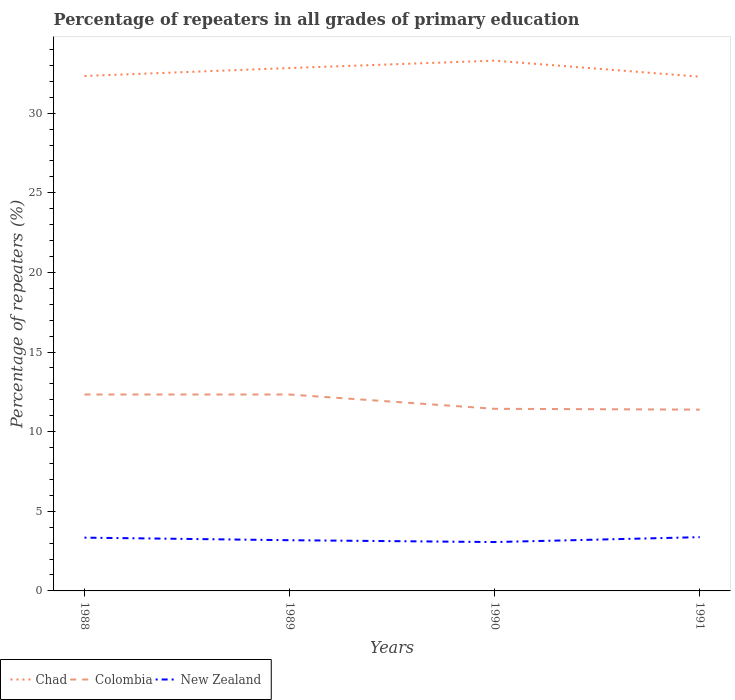Does the line corresponding to Chad intersect with the line corresponding to Colombia?
Keep it short and to the point. No. Is the number of lines equal to the number of legend labels?
Your answer should be very brief. Yes. Across all years, what is the maximum percentage of repeaters in Colombia?
Make the answer very short. 11.39. In which year was the percentage of repeaters in Chad maximum?
Provide a succinct answer. 1991. What is the total percentage of repeaters in Colombia in the graph?
Offer a very short reply. 0.9. What is the difference between the highest and the second highest percentage of repeaters in Chad?
Keep it short and to the point. 1.01. What is the difference between the highest and the lowest percentage of repeaters in Chad?
Provide a succinct answer. 2. How many years are there in the graph?
Your response must be concise. 4. Does the graph contain grids?
Ensure brevity in your answer.  No. How many legend labels are there?
Provide a succinct answer. 3. What is the title of the graph?
Your response must be concise. Percentage of repeaters in all grades of primary education. What is the label or title of the Y-axis?
Your answer should be very brief. Percentage of repeaters (%). What is the Percentage of repeaters (%) of Chad in 1988?
Offer a very short reply. 32.34. What is the Percentage of repeaters (%) in Colombia in 1988?
Keep it short and to the point. 12.33. What is the Percentage of repeaters (%) in New Zealand in 1988?
Your answer should be compact. 3.35. What is the Percentage of repeaters (%) in Chad in 1989?
Offer a very short reply. 32.84. What is the Percentage of repeaters (%) of Colombia in 1989?
Offer a terse response. 12.33. What is the Percentage of repeaters (%) in New Zealand in 1989?
Make the answer very short. 3.18. What is the Percentage of repeaters (%) in Chad in 1990?
Your response must be concise. 33.3. What is the Percentage of repeaters (%) of Colombia in 1990?
Make the answer very short. 11.44. What is the Percentage of repeaters (%) in New Zealand in 1990?
Provide a short and direct response. 3.07. What is the Percentage of repeaters (%) in Chad in 1991?
Ensure brevity in your answer.  32.29. What is the Percentage of repeaters (%) in Colombia in 1991?
Provide a short and direct response. 11.39. What is the Percentage of repeaters (%) of New Zealand in 1991?
Offer a very short reply. 3.38. Across all years, what is the maximum Percentage of repeaters (%) of Chad?
Provide a succinct answer. 33.3. Across all years, what is the maximum Percentage of repeaters (%) of Colombia?
Your response must be concise. 12.33. Across all years, what is the maximum Percentage of repeaters (%) in New Zealand?
Provide a short and direct response. 3.38. Across all years, what is the minimum Percentage of repeaters (%) in Chad?
Ensure brevity in your answer.  32.29. Across all years, what is the minimum Percentage of repeaters (%) in Colombia?
Give a very brief answer. 11.39. Across all years, what is the minimum Percentage of repeaters (%) of New Zealand?
Give a very brief answer. 3.07. What is the total Percentage of repeaters (%) in Chad in the graph?
Keep it short and to the point. 130.78. What is the total Percentage of repeaters (%) of Colombia in the graph?
Offer a terse response. 47.49. What is the total Percentage of repeaters (%) of New Zealand in the graph?
Your answer should be very brief. 12.98. What is the difference between the Percentage of repeaters (%) of Chad in 1988 and that in 1989?
Your answer should be very brief. -0.5. What is the difference between the Percentage of repeaters (%) in New Zealand in 1988 and that in 1989?
Your answer should be compact. 0.16. What is the difference between the Percentage of repeaters (%) in Chad in 1988 and that in 1990?
Offer a very short reply. -0.96. What is the difference between the Percentage of repeaters (%) of Colombia in 1988 and that in 1990?
Offer a very short reply. 0.9. What is the difference between the Percentage of repeaters (%) in New Zealand in 1988 and that in 1990?
Your answer should be compact. 0.28. What is the difference between the Percentage of repeaters (%) in Chad in 1988 and that in 1991?
Offer a terse response. 0.05. What is the difference between the Percentage of repeaters (%) of Colombia in 1988 and that in 1991?
Make the answer very short. 0.95. What is the difference between the Percentage of repeaters (%) of New Zealand in 1988 and that in 1991?
Your answer should be very brief. -0.03. What is the difference between the Percentage of repeaters (%) of Chad in 1989 and that in 1990?
Offer a very short reply. -0.46. What is the difference between the Percentage of repeaters (%) of Colombia in 1989 and that in 1990?
Give a very brief answer. 0.9. What is the difference between the Percentage of repeaters (%) in New Zealand in 1989 and that in 1990?
Your answer should be compact. 0.12. What is the difference between the Percentage of repeaters (%) of Chad in 1989 and that in 1991?
Keep it short and to the point. 0.54. What is the difference between the Percentage of repeaters (%) in Colombia in 1989 and that in 1991?
Your answer should be compact. 0.95. What is the difference between the Percentage of repeaters (%) in New Zealand in 1989 and that in 1991?
Make the answer very short. -0.19. What is the difference between the Percentage of repeaters (%) in Chad in 1990 and that in 1991?
Keep it short and to the point. 1.01. What is the difference between the Percentage of repeaters (%) in Colombia in 1990 and that in 1991?
Provide a succinct answer. 0.05. What is the difference between the Percentage of repeaters (%) of New Zealand in 1990 and that in 1991?
Your answer should be very brief. -0.31. What is the difference between the Percentage of repeaters (%) in Chad in 1988 and the Percentage of repeaters (%) in Colombia in 1989?
Provide a succinct answer. 20.01. What is the difference between the Percentage of repeaters (%) of Chad in 1988 and the Percentage of repeaters (%) of New Zealand in 1989?
Give a very brief answer. 29.16. What is the difference between the Percentage of repeaters (%) in Colombia in 1988 and the Percentage of repeaters (%) in New Zealand in 1989?
Offer a terse response. 9.15. What is the difference between the Percentage of repeaters (%) in Chad in 1988 and the Percentage of repeaters (%) in Colombia in 1990?
Offer a very short reply. 20.9. What is the difference between the Percentage of repeaters (%) in Chad in 1988 and the Percentage of repeaters (%) in New Zealand in 1990?
Your answer should be very brief. 29.27. What is the difference between the Percentage of repeaters (%) in Colombia in 1988 and the Percentage of repeaters (%) in New Zealand in 1990?
Ensure brevity in your answer.  9.27. What is the difference between the Percentage of repeaters (%) of Chad in 1988 and the Percentage of repeaters (%) of Colombia in 1991?
Your response must be concise. 20.95. What is the difference between the Percentage of repeaters (%) in Chad in 1988 and the Percentage of repeaters (%) in New Zealand in 1991?
Make the answer very short. 28.96. What is the difference between the Percentage of repeaters (%) in Colombia in 1988 and the Percentage of repeaters (%) in New Zealand in 1991?
Offer a terse response. 8.96. What is the difference between the Percentage of repeaters (%) of Chad in 1989 and the Percentage of repeaters (%) of Colombia in 1990?
Give a very brief answer. 21.4. What is the difference between the Percentage of repeaters (%) in Chad in 1989 and the Percentage of repeaters (%) in New Zealand in 1990?
Your response must be concise. 29.77. What is the difference between the Percentage of repeaters (%) in Colombia in 1989 and the Percentage of repeaters (%) in New Zealand in 1990?
Your answer should be very brief. 9.27. What is the difference between the Percentage of repeaters (%) in Chad in 1989 and the Percentage of repeaters (%) in Colombia in 1991?
Provide a short and direct response. 21.45. What is the difference between the Percentage of repeaters (%) in Chad in 1989 and the Percentage of repeaters (%) in New Zealand in 1991?
Offer a terse response. 29.46. What is the difference between the Percentage of repeaters (%) of Colombia in 1989 and the Percentage of repeaters (%) of New Zealand in 1991?
Ensure brevity in your answer.  8.96. What is the difference between the Percentage of repeaters (%) in Chad in 1990 and the Percentage of repeaters (%) in Colombia in 1991?
Provide a short and direct response. 21.92. What is the difference between the Percentage of repeaters (%) of Chad in 1990 and the Percentage of repeaters (%) of New Zealand in 1991?
Your response must be concise. 29.93. What is the difference between the Percentage of repeaters (%) of Colombia in 1990 and the Percentage of repeaters (%) of New Zealand in 1991?
Offer a terse response. 8.06. What is the average Percentage of repeaters (%) of Chad per year?
Keep it short and to the point. 32.69. What is the average Percentage of repeaters (%) in Colombia per year?
Keep it short and to the point. 11.87. What is the average Percentage of repeaters (%) in New Zealand per year?
Your response must be concise. 3.24. In the year 1988, what is the difference between the Percentage of repeaters (%) of Chad and Percentage of repeaters (%) of Colombia?
Your response must be concise. 20.01. In the year 1988, what is the difference between the Percentage of repeaters (%) of Chad and Percentage of repeaters (%) of New Zealand?
Give a very brief answer. 28.99. In the year 1988, what is the difference between the Percentage of repeaters (%) in Colombia and Percentage of repeaters (%) in New Zealand?
Give a very brief answer. 8.99. In the year 1989, what is the difference between the Percentage of repeaters (%) in Chad and Percentage of repeaters (%) in Colombia?
Provide a succinct answer. 20.5. In the year 1989, what is the difference between the Percentage of repeaters (%) of Chad and Percentage of repeaters (%) of New Zealand?
Give a very brief answer. 29.65. In the year 1989, what is the difference between the Percentage of repeaters (%) in Colombia and Percentage of repeaters (%) in New Zealand?
Keep it short and to the point. 9.15. In the year 1990, what is the difference between the Percentage of repeaters (%) in Chad and Percentage of repeaters (%) in Colombia?
Give a very brief answer. 21.86. In the year 1990, what is the difference between the Percentage of repeaters (%) in Chad and Percentage of repeaters (%) in New Zealand?
Keep it short and to the point. 30.23. In the year 1990, what is the difference between the Percentage of repeaters (%) in Colombia and Percentage of repeaters (%) in New Zealand?
Your answer should be very brief. 8.37. In the year 1991, what is the difference between the Percentage of repeaters (%) of Chad and Percentage of repeaters (%) of Colombia?
Your response must be concise. 20.91. In the year 1991, what is the difference between the Percentage of repeaters (%) of Chad and Percentage of repeaters (%) of New Zealand?
Ensure brevity in your answer.  28.92. In the year 1991, what is the difference between the Percentage of repeaters (%) of Colombia and Percentage of repeaters (%) of New Zealand?
Your response must be concise. 8.01. What is the ratio of the Percentage of repeaters (%) of New Zealand in 1988 to that in 1989?
Your answer should be compact. 1.05. What is the ratio of the Percentage of repeaters (%) in Chad in 1988 to that in 1990?
Give a very brief answer. 0.97. What is the ratio of the Percentage of repeaters (%) of Colombia in 1988 to that in 1990?
Make the answer very short. 1.08. What is the ratio of the Percentage of repeaters (%) in New Zealand in 1988 to that in 1990?
Your response must be concise. 1.09. What is the ratio of the Percentage of repeaters (%) in Chad in 1988 to that in 1991?
Ensure brevity in your answer.  1. What is the ratio of the Percentage of repeaters (%) of Colombia in 1988 to that in 1991?
Make the answer very short. 1.08. What is the ratio of the Percentage of repeaters (%) in New Zealand in 1988 to that in 1991?
Offer a very short reply. 0.99. What is the ratio of the Percentage of repeaters (%) of Chad in 1989 to that in 1990?
Your response must be concise. 0.99. What is the ratio of the Percentage of repeaters (%) in Colombia in 1989 to that in 1990?
Offer a very short reply. 1.08. What is the ratio of the Percentage of repeaters (%) in New Zealand in 1989 to that in 1990?
Your answer should be compact. 1.04. What is the ratio of the Percentage of repeaters (%) of Chad in 1989 to that in 1991?
Offer a very short reply. 1.02. What is the ratio of the Percentage of repeaters (%) of Colombia in 1989 to that in 1991?
Your answer should be compact. 1.08. What is the ratio of the Percentage of repeaters (%) in New Zealand in 1989 to that in 1991?
Your answer should be very brief. 0.94. What is the ratio of the Percentage of repeaters (%) of Chad in 1990 to that in 1991?
Offer a terse response. 1.03. What is the difference between the highest and the second highest Percentage of repeaters (%) in Chad?
Provide a succinct answer. 0.46. What is the difference between the highest and the lowest Percentage of repeaters (%) in Colombia?
Your answer should be compact. 0.95. What is the difference between the highest and the lowest Percentage of repeaters (%) of New Zealand?
Provide a short and direct response. 0.31. 